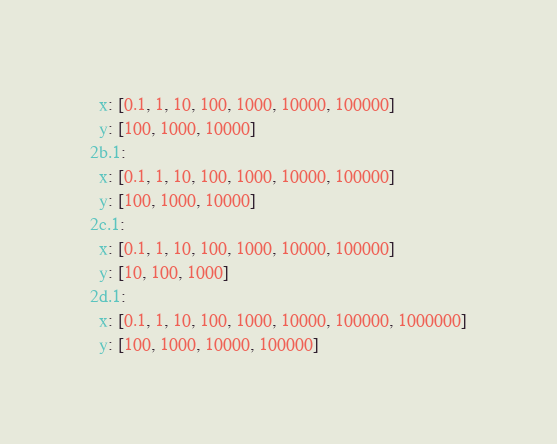<code> <loc_0><loc_0><loc_500><loc_500><_YAML_>  x: [0.1, 1, 10, 100, 1000, 10000, 100000]
  y: [100, 1000, 10000]
2b.1:
  x: [0.1, 1, 10, 100, 1000, 10000, 100000]
  y: [100, 1000, 10000]
2c.1:
  x: [0.1, 1, 10, 100, 1000, 10000, 100000]
  y: [10, 100, 1000]
2d.1:
  x: [0.1, 1, 10, 100, 1000, 10000, 100000, 1000000]
  y: [100, 1000, 10000, 100000]
</code> 